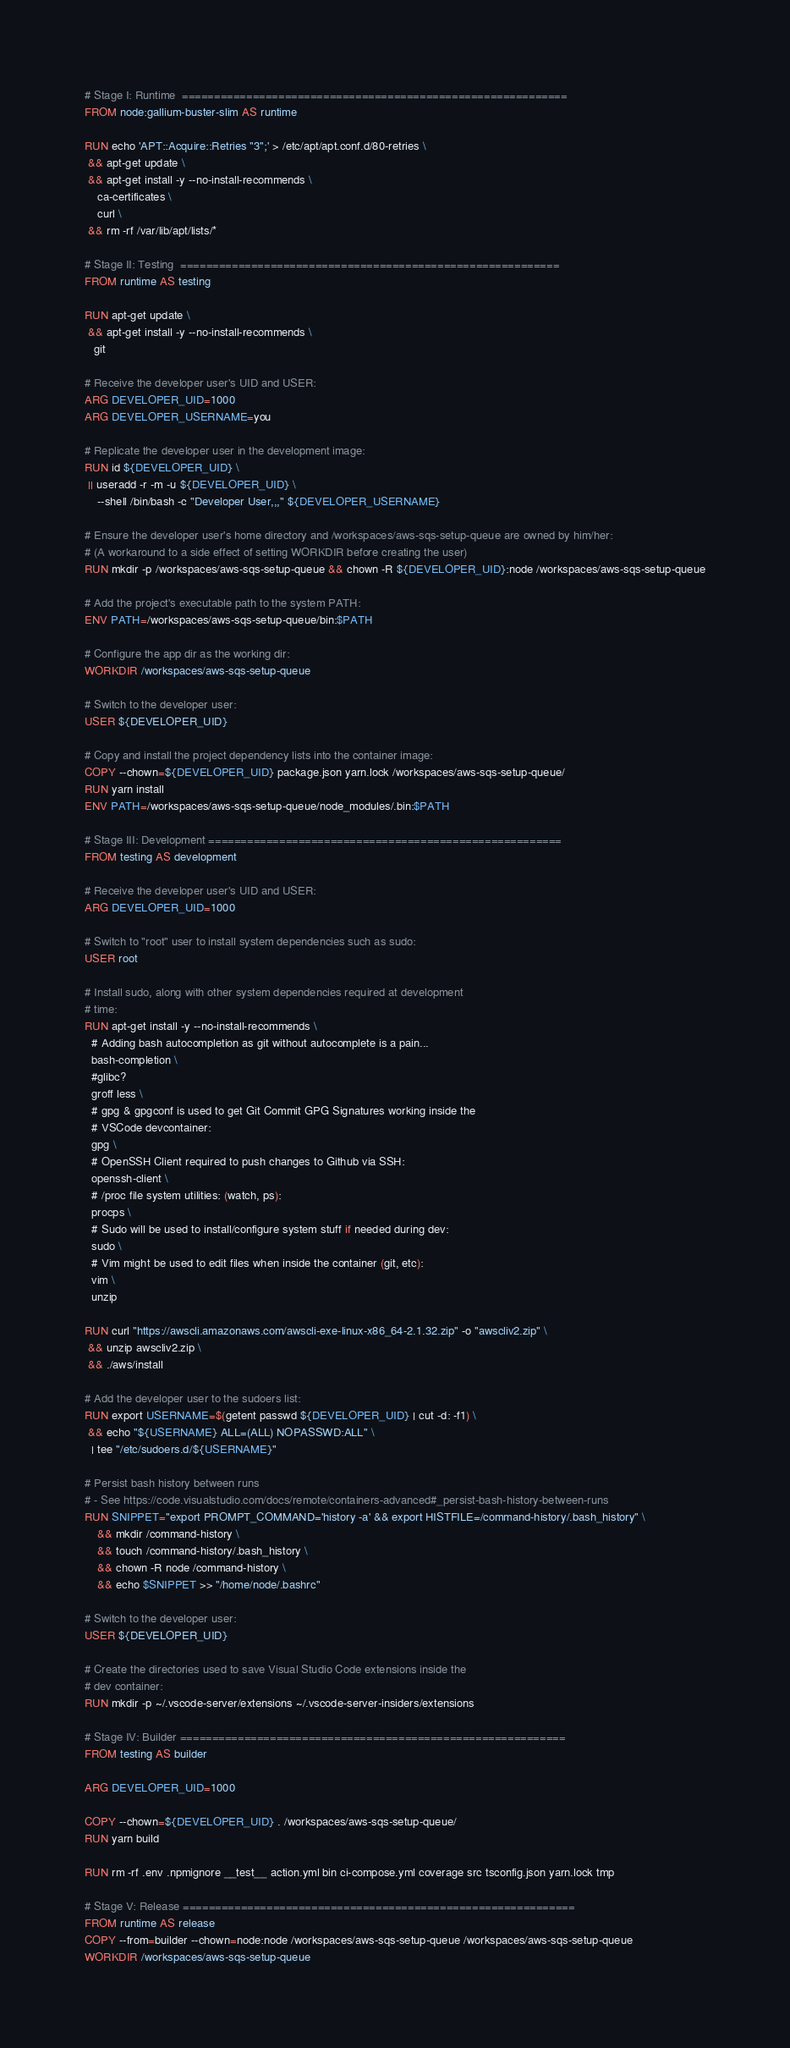<code> <loc_0><loc_0><loc_500><loc_500><_Dockerfile_># Stage I: Runtime  ============================================================
FROM node:gallium-buster-slim AS runtime

RUN echo 'APT::Acquire::Retries "3";' > /etc/apt/apt.conf.d/80-retries \
 && apt-get update \
 && apt-get install -y --no-install-recommends \
    ca-certificates \
    curl \
 && rm -rf /var/lib/apt/lists/*

# Stage II: Testing  ===========================================================
FROM runtime AS testing

RUN apt-get update \
 && apt-get install -y --no-install-recommends \
   git

# Receive the developer user's UID and USER:
ARG DEVELOPER_UID=1000
ARG DEVELOPER_USERNAME=you

# Replicate the developer user in the development image:
RUN id ${DEVELOPER_UID} \
 || useradd -r -m -u ${DEVELOPER_UID} \
    --shell /bin/bash -c "Developer User,,," ${DEVELOPER_USERNAME}

# Ensure the developer user's home directory and /workspaces/aws-sqs-setup-queue are owned by him/her:
# (A workaround to a side effect of setting WORKDIR before creating the user)
RUN mkdir -p /workspaces/aws-sqs-setup-queue && chown -R ${DEVELOPER_UID}:node /workspaces/aws-sqs-setup-queue

# Add the project's executable path to the system PATH:
ENV PATH=/workspaces/aws-sqs-setup-queue/bin:$PATH

# Configure the app dir as the working dir:
WORKDIR /workspaces/aws-sqs-setup-queue

# Switch to the developer user:
USER ${DEVELOPER_UID}

# Copy and install the project dependency lists into the container image:
COPY --chown=${DEVELOPER_UID} package.json yarn.lock /workspaces/aws-sqs-setup-queue/
RUN yarn install
ENV PATH=/workspaces/aws-sqs-setup-queue/node_modules/.bin:$PATH

# Stage III: Development =======================================================
FROM testing AS development

# Receive the developer user's UID and USER:
ARG DEVELOPER_UID=1000

# Switch to "root" user to install system dependencies such as sudo:
USER root

# Install sudo, along with other system dependencies required at development
# time:
RUN apt-get install -y --no-install-recommends \
  # Adding bash autocompletion as git without autocomplete is a pain...
  bash-completion \
  #glibc?
  groff less \
  # gpg & gpgconf is used to get Git Commit GPG Signatures working inside the 
  # VSCode devcontainer:
  gpg \
  # OpenSSH Client required to push changes to Github via SSH:
  openssh-client \
  # /proc file system utilities: (watch, ps):
  procps \
  # Sudo will be used to install/configure system stuff if needed during dev:
  sudo \
  # Vim might be used to edit files when inside the container (git, etc):
  vim \
  unzip

RUN curl "https://awscli.amazonaws.com/awscli-exe-linux-x86_64-2.1.32.zip" -o "awscliv2.zip" \
 && unzip awscliv2.zip \
 && ./aws/install

# Add the developer user to the sudoers list:
RUN export USERNAME=$(getent passwd ${DEVELOPER_UID} | cut -d: -f1) \
 && echo "${USERNAME} ALL=(ALL) NOPASSWD:ALL" \
  | tee "/etc/sudoers.d/${USERNAME}"

# Persist bash history between runs
# - See https://code.visualstudio.com/docs/remote/containers-advanced#_persist-bash-history-between-runs
RUN SNIPPET="export PROMPT_COMMAND='history -a' && export HISTFILE=/command-history/.bash_history" \
    && mkdir /command-history \
    && touch /command-history/.bash_history \
    && chown -R node /command-history \
    && echo $SNIPPET >> "/home/node/.bashrc"

# Switch to the developer user:
USER ${DEVELOPER_UID}

# Create the directories used to save Visual Studio Code extensions inside the
# dev container:
RUN mkdir -p ~/.vscode-server/extensions ~/.vscode-server-insiders/extensions

# Stage IV: Builder ============================================================
FROM testing AS builder

ARG DEVELOPER_UID=1000

COPY --chown=${DEVELOPER_UID} . /workspaces/aws-sqs-setup-queue/
RUN yarn build

RUN rm -rf .env .npmignore __test__ action.yml bin ci-compose.yml coverage src tsconfig.json yarn.lock tmp

# Stage V: Release =============================================================
FROM runtime AS release
COPY --from=builder --chown=node:node /workspaces/aws-sqs-setup-queue /workspaces/aws-sqs-setup-queue
WORKDIR /workspaces/aws-sqs-setup-queue
</code> 